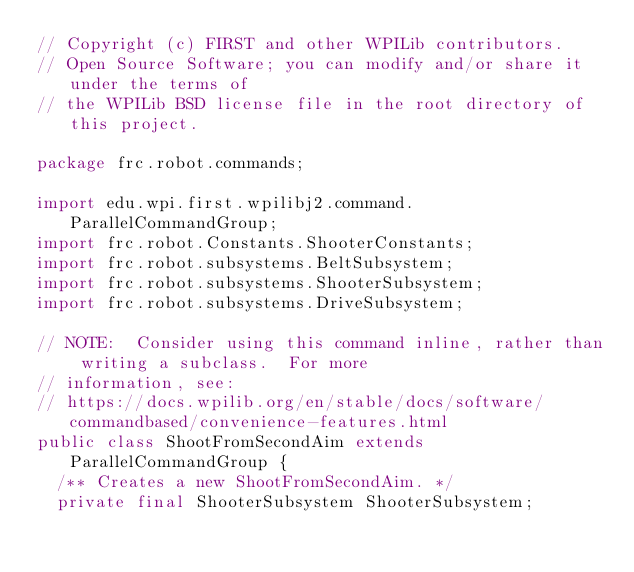Convert code to text. <code><loc_0><loc_0><loc_500><loc_500><_Java_>// Copyright (c) FIRST and other WPILib contributors.
// Open Source Software; you can modify and/or share it under the terms of
// the WPILib BSD license file in the root directory of this project.

package frc.robot.commands;

import edu.wpi.first.wpilibj2.command.ParallelCommandGroup;
import frc.robot.Constants.ShooterConstants;
import frc.robot.subsystems.BeltSubsystem;
import frc.robot.subsystems.ShooterSubsystem;
import frc.robot.subsystems.DriveSubsystem;

// NOTE:  Consider using this command inline, rather than writing a subclass.  For more
// information, see:
// https://docs.wpilib.org/en/stable/docs/software/commandbased/convenience-features.html
public class ShootFromSecondAim extends ParallelCommandGroup {
  /** Creates a new ShootFromSecondAim. */
  private final ShooterSubsystem ShooterSubsystem;</code> 